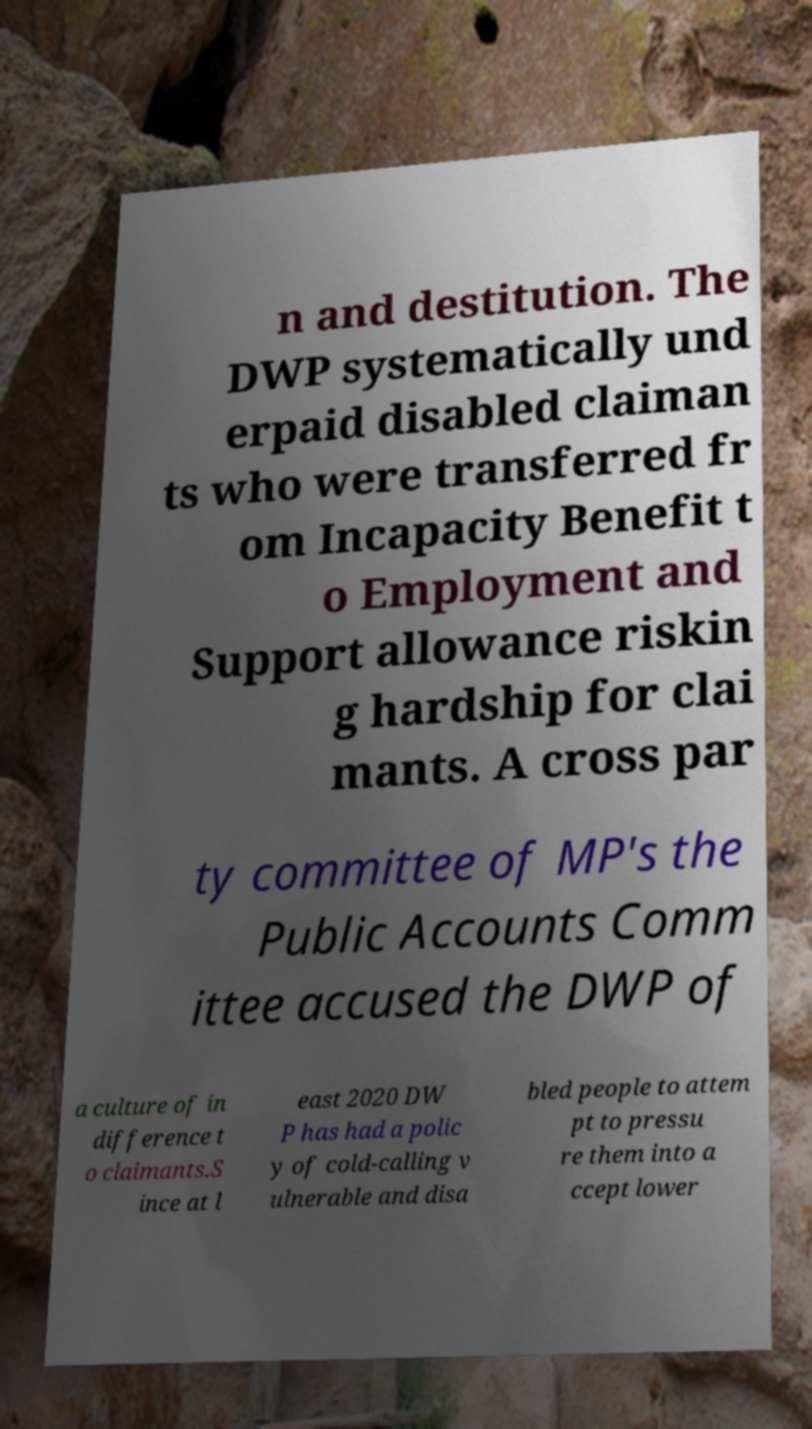For documentation purposes, I need the text within this image transcribed. Could you provide that? n and destitution. The DWP systematically und erpaid disabled claiman ts who were transferred fr om Incapacity Benefit t o Employment and Support allowance riskin g hardship for clai mants. A cross par ty committee of MP's the Public Accounts Comm ittee accused the DWP of a culture of in difference t o claimants.S ince at l east 2020 DW P has had a polic y of cold-calling v ulnerable and disa bled people to attem pt to pressu re them into a ccept lower 